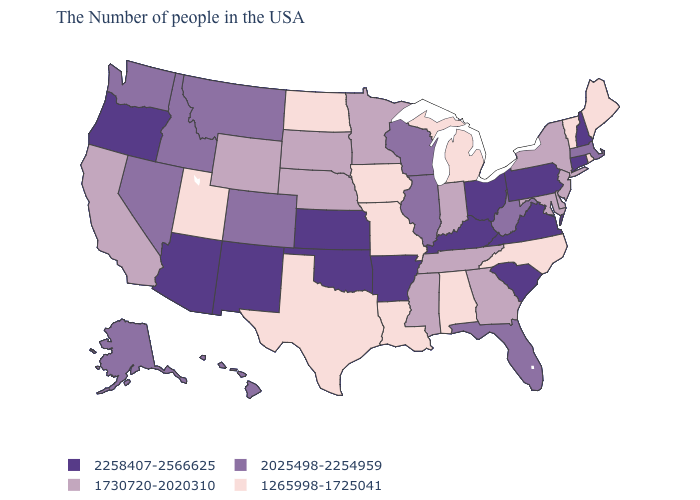Does the map have missing data?
Short answer required. No. Name the states that have a value in the range 1265998-1725041?
Write a very short answer. Maine, Rhode Island, Vermont, North Carolina, Michigan, Alabama, Louisiana, Missouri, Iowa, Texas, North Dakota, Utah. How many symbols are there in the legend?
Quick response, please. 4. Among the states that border Georgia , which have the lowest value?
Give a very brief answer. North Carolina, Alabama. What is the value of Indiana?
Short answer required. 1730720-2020310. Among the states that border Washington , which have the lowest value?
Concise answer only. Idaho. Does the first symbol in the legend represent the smallest category?
Write a very short answer. No. Among the states that border Iowa , which have the highest value?
Concise answer only. Wisconsin, Illinois. What is the highest value in states that border New Jersey?
Short answer required. 2258407-2566625. What is the lowest value in the South?
Write a very short answer. 1265998-1725041. Name the states that have a value in the range 2258407-2566625?
Be succinct. New Hampshire, Connecticut, Pennsylvania, Virginia, South Carolina, Ohio, Kentucky, Arkansas, Kansas, Oklahoma, New Mexico, Arizona, Oregon. Is the legend a continuous bar?
Short answer required. No. Name the states that have a value in the range 1265998-1725041?
Give a very brief answer. Maine, Rhode Island, Vermont, North Carolina, Michigan, Alabama, Louisiana, Missouri, Iowa, Texas, North Dakota, Utah. Name the states that have a value in the range 2258407-2566625?
Be succinct. New Hampshire, Connecticut, Pennsylvania, Virginia, South Carolina, Ohio, Kentucky, Arkansas, Kansas, Oklahoma, New Mexico, Arizona, Oregon. Does Nebraska have a higher value than Iowa?
Give a very brief answer. Yes. 